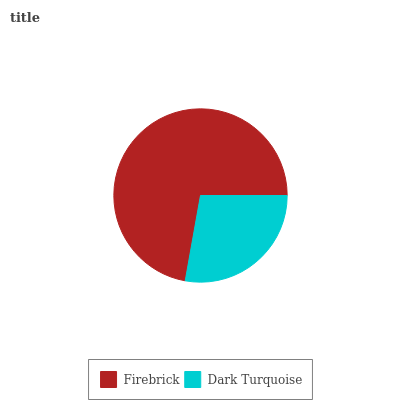Is Dark Turquoise the minimum?
Answer yes or no. Yes. Is Firebrick the maximum?
Answer yes or no. Yes. Is Dark Turquoise the maximum?
Answer yes or no. No. Is Firebrick greater than Dark Turquoise?
Answer yes or no. Yes. Is Dark Turquoise less than Firebrick?
Answer yes or no. Yes. Is Dark Turquoise greater than Firebrick?
Answer yes or no. No. Is Firebrick less than Dark Turquoise?
Answer yes or no. No. Is Firebrick the high median?
Answer yes or no. Yes. Is Dark Turquoise the low median?
Answer yes or no. Yes. Is Dark Turquoise the high median?
Answer yes or no. No. Is Firebrick the low median?
Answer yes or no. No. 